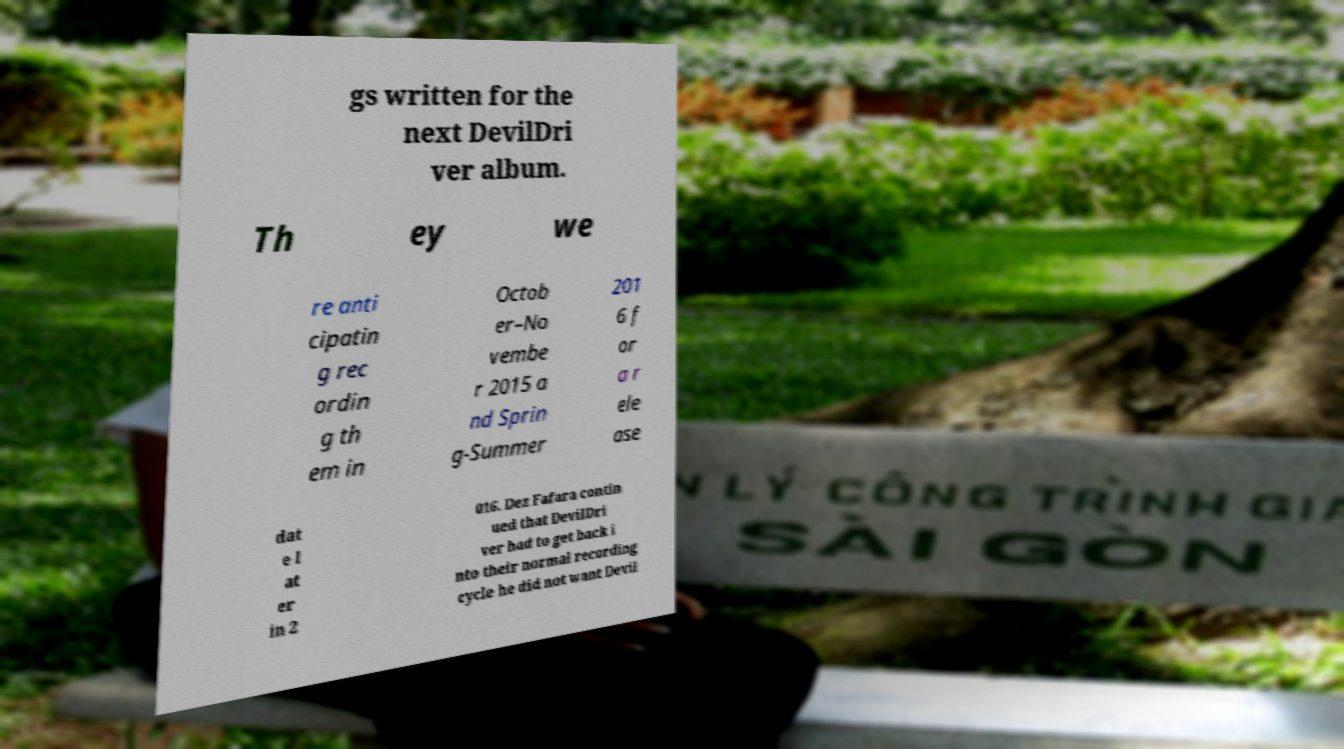Please identify and transcribe the text found in this image. gs written for the next DevilDri ver album. Th ey we re anti cipatin g rec ordin g th em in Octob er–No vembe r 2015 a nd Sprin g-Summer 201 6 f or a r ele ase dat e l at er in 2 016. Dez Fafara contin ued that DevilDri ver had to get back i nto their normal recording cycle he did not want Devil 